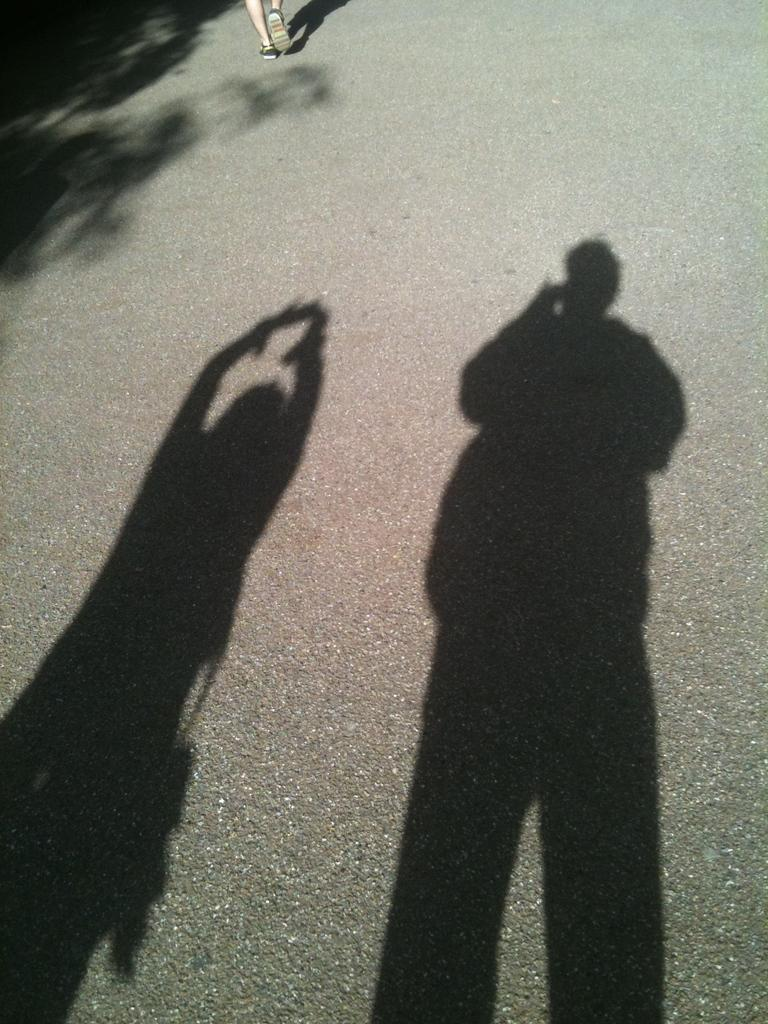What is the main feature of the image? There is a road in the image. Can you describe any other elements in the image? Shadows of two persons are visible on the road. Where are the legs of a person located in the image? The legs of a person are visible at the top of the image. What type of leaf is falling on the road in the image? There is no leaf present in the image; only the road, shadows of two persons, and legs of a person are visible. 